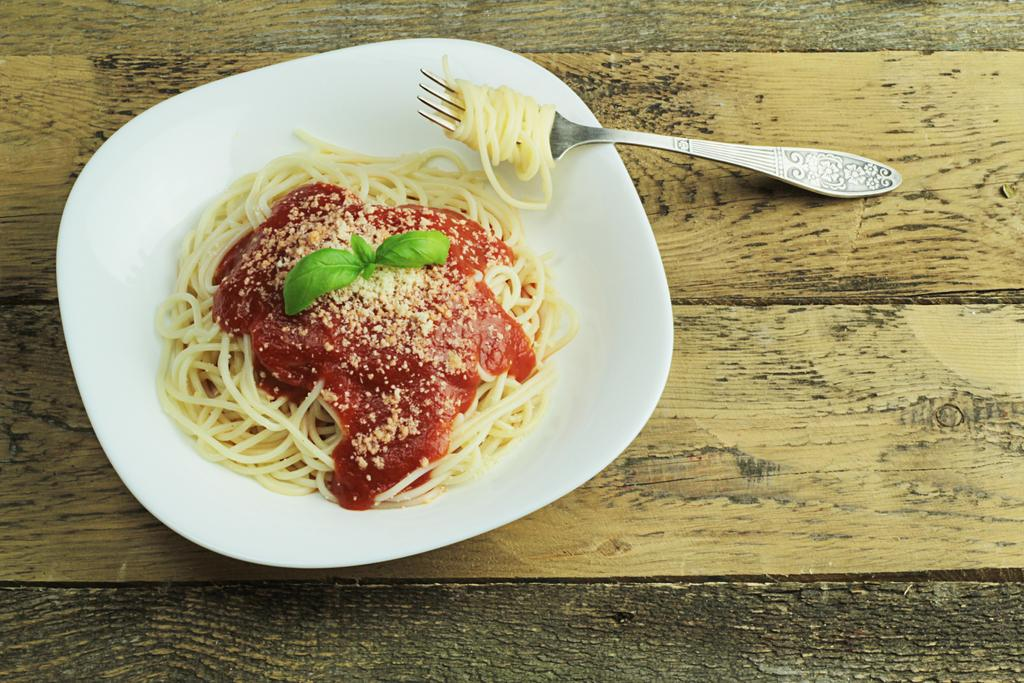What is in the bowl that is visible in the image? There is a bowl of noodles in the image. What is on top of the noodles in the bowl? The bowl of noodles has sauce on it, and mint leaves are present on the bowl of noodles. What utensil is visible in the image? There is a fork in the image. What type of table is visible in the image? The wooden table is visible in the image. What type of record is being played in the image? There is no record or music player present in the image; it features a bowl of noodles with sauce and mint leaves, a fork, and a wooden table. 